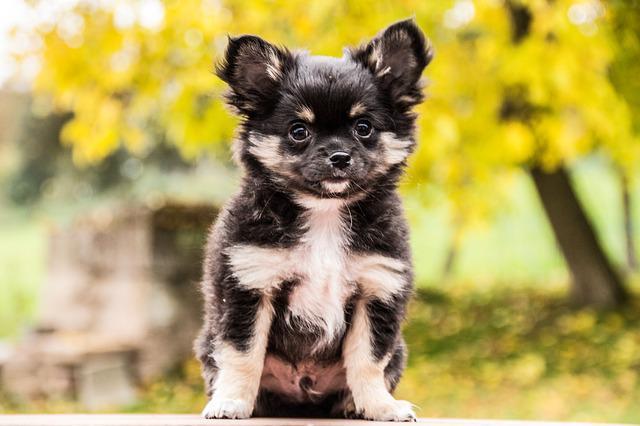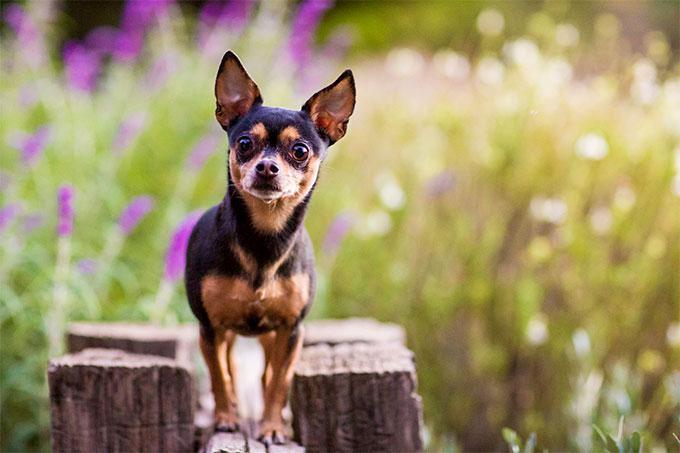The first image is the image on the left, the second image is the image on the right. Given the left and right images, does the statement "Both dogs are looking toward the camera." hold true? Answer yes or no. Yes. 